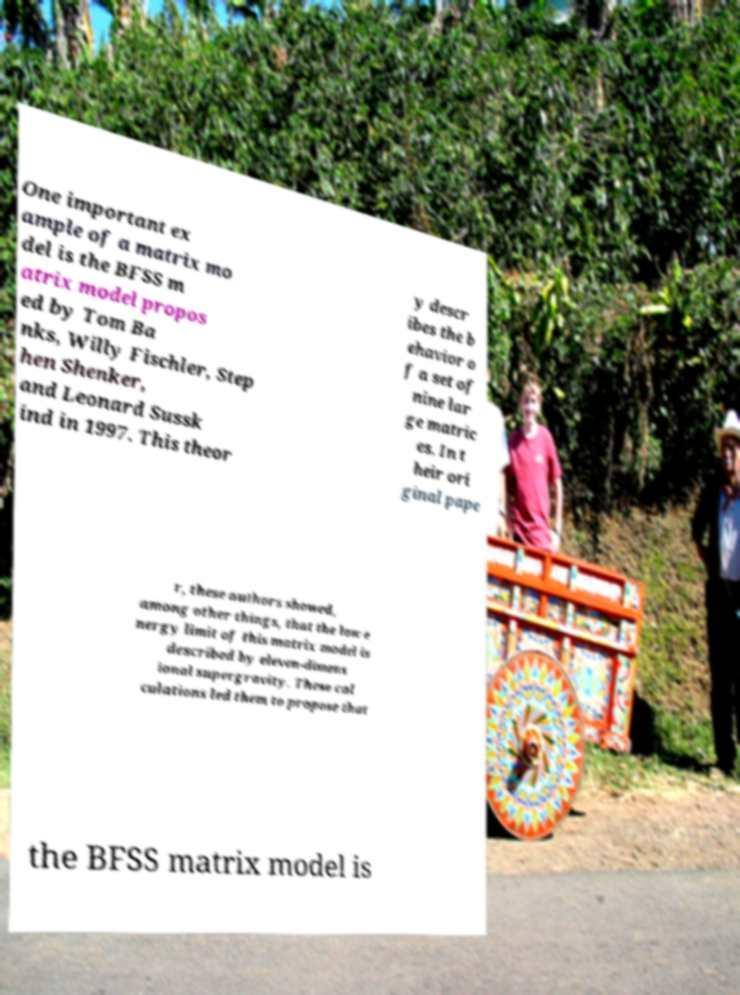What messages or text are displayed in this image? I need them in a readable, typed format. One important ex ample of a matrix mo del is the BFSS m atrix model propos ed by Tom Ba nks, Willy Fischler, Step hen Shenker, and Leonard Sussk ind in 1997. This theor y descr ibes the b ehavior o f a set of nine lar ge matric es. In t heir ori ginal pape r, these authors showed, among other things, that the low e nergy limit of this matrix model is described by eleven-dimens ional supergravity. These cal culations led them to propose that the BFSS matrix model is 